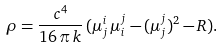<formula> <loc_0><loc_0><loc_500><loc_500>\rho = \frac { c ^ { 4 } } { 1 6 \, \pi \, k } \, ( \mu ^ { i } _ { j } \, \mu ^ { j } _ { i } - ( \mu ^ { j } _ { j } ) ^ { 2 } - R ) .</formula> 